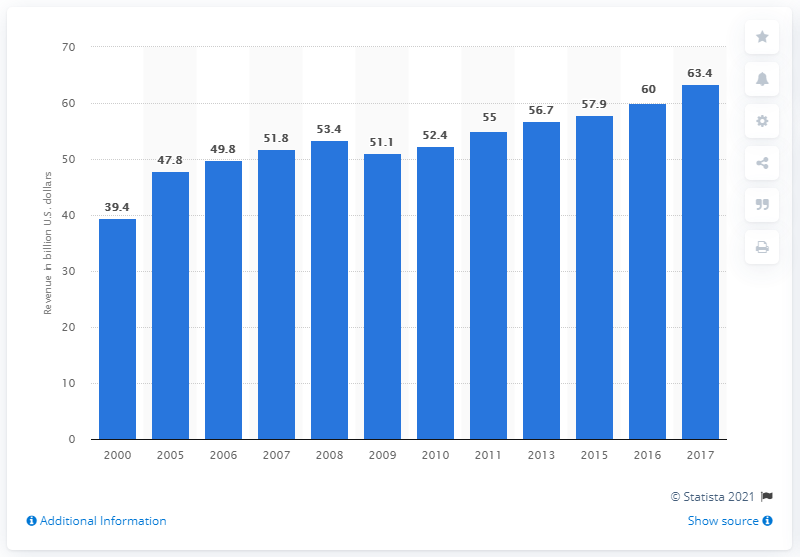List a handful of essential elements in this visual. In 2017, the solid waste industry in the United States generated approximately $63.4 billion in revenue. 